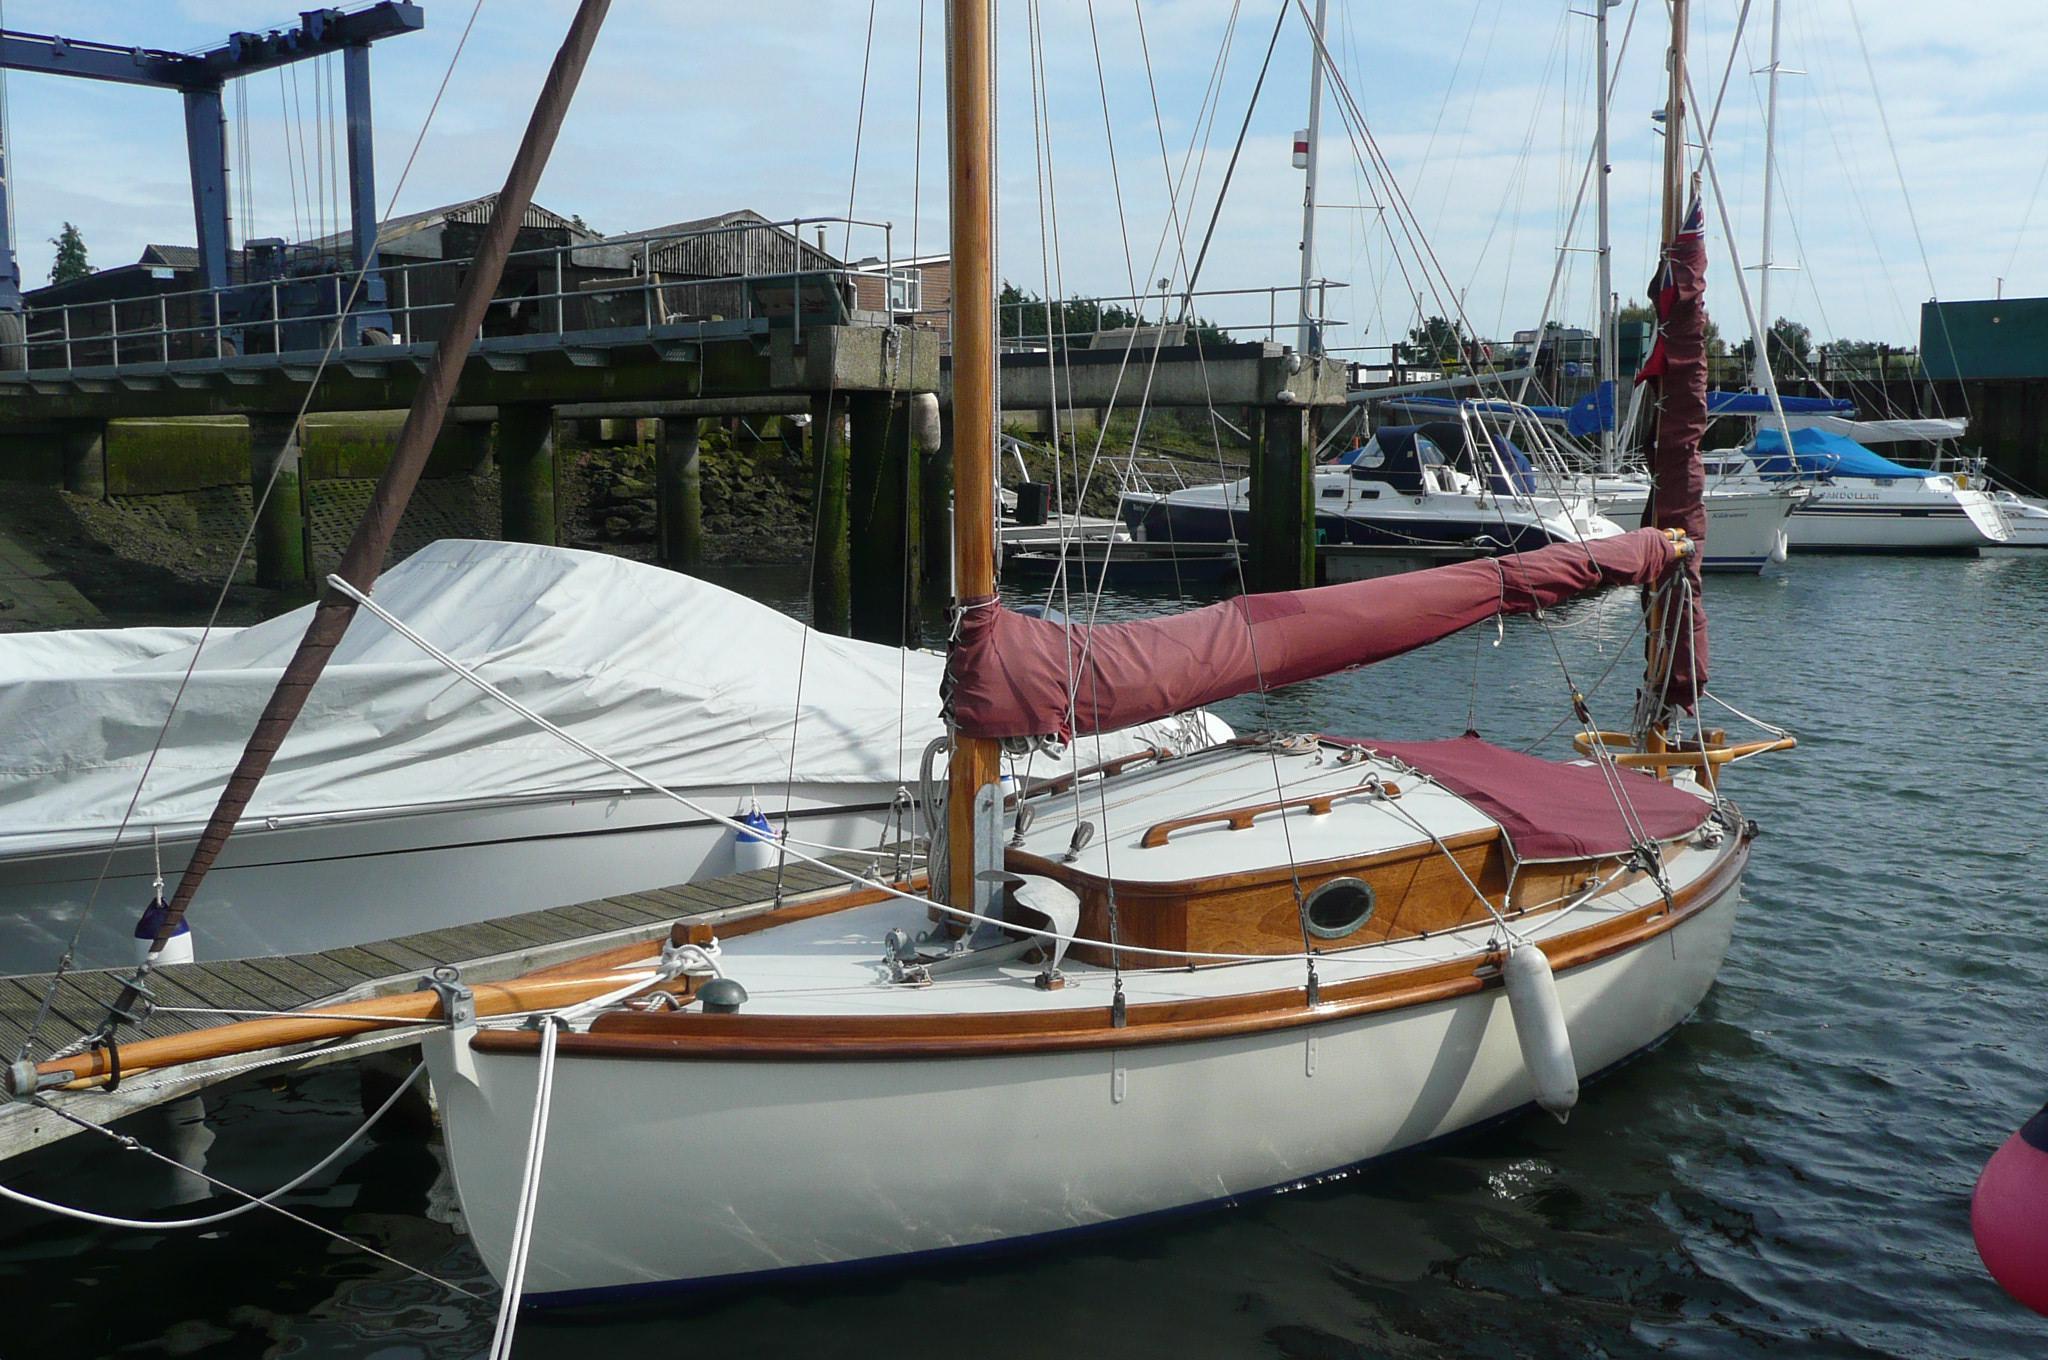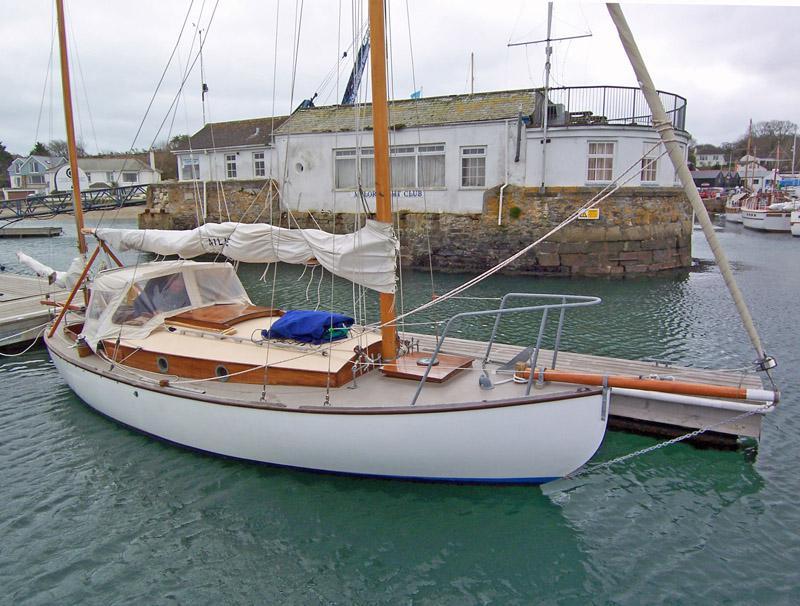The first image is the image on the left, the second image is the image on the right. Analyze the images presented: Is the assertion "An image shows a line of boats with unfurled sails moored alongside a dock." valid? Answer yes or no. No. 